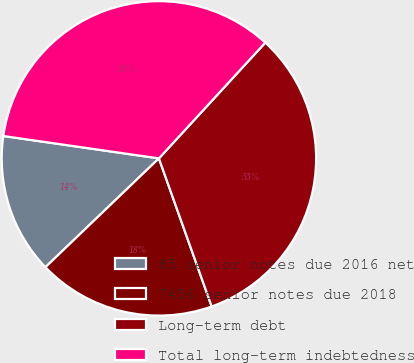Convert chart. <chart><loc_0><loc_0><loc_500><loc_500><pie_chart><fcel>85 senior notes due 2016 net<fcel>7456 senior notes due 2018<fcel>Long-term debt<fcel>Total long-term indebtedness<nl><fcel>14.44%<fcel>18.28%<fcel>32.72%<fcel>34.55%<nl></chart> 